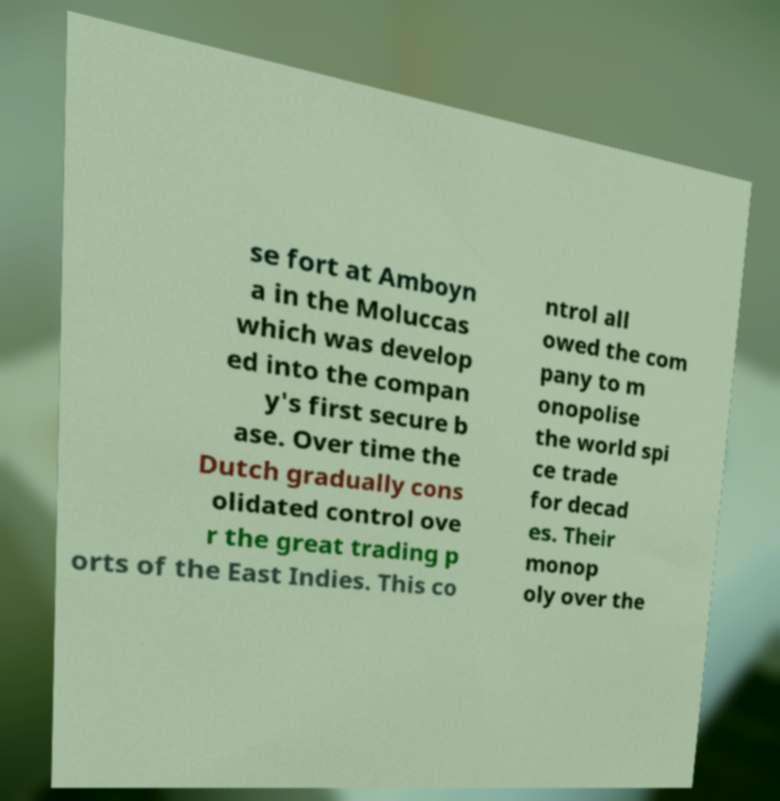There's text embedded in this image that I need extracted. Can you transcribe it verbatim? se fort at Amboyn a in the Moluccas which was develop ed into the compan y's first secure b ase. Over time the Dutch gradually cons olidated control ove r the great trading p orts of the East Indies. This co ntrol all owed the com pany to m onopolise the world spi ce trade for decad es. Their monop oly over the 